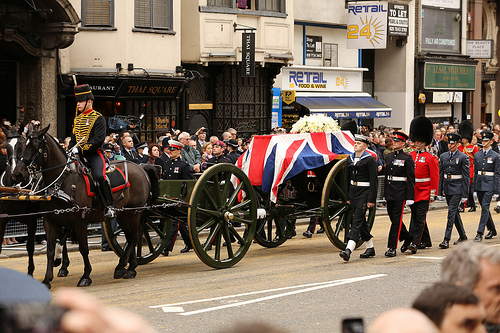What vehicle is green? The green vehicle is a wagon. 